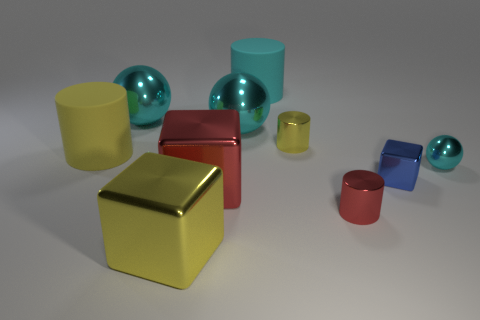What material is the other cube that is the same size as the yellow metallic block?
Your answer should be compact. Metal. What number of other things are there of the same material as the big yellow cylinder
Provide a short and direct response. 1. The cyan shiny thing that is on the right side of the metal cylinder that is behind the tiny shiny block is what shape?
Provide a short and direct response. Sphere. How many objects are either shiny objects or cyan balls that are behind the small cyan ball?
Your answer should be compact. 8. How many other things are there of the same color as the tiny ball?
Provide a short and direct response. 3. What number of green objects are either metal objects or small things?
Ensure brevity in your answer.  0. There is a cylinder that is to the right of the small metallic cylinder that is behind the tiny blue thing; is there a cyan rubber object that is on the right side of it?
Provide a short and direct response. No. Is there anything else that is the same size as the yellow rubber thing?
Offer a terse response. Yes. Is the color of the small metallic cube the same as the tiny shiny ball?
Provide a short and direct response. No. There is a cylinder in front of the yellow cylinder to the left of the large cyan matte cylinder; what is its color?
Offer a very short reply. Red. 